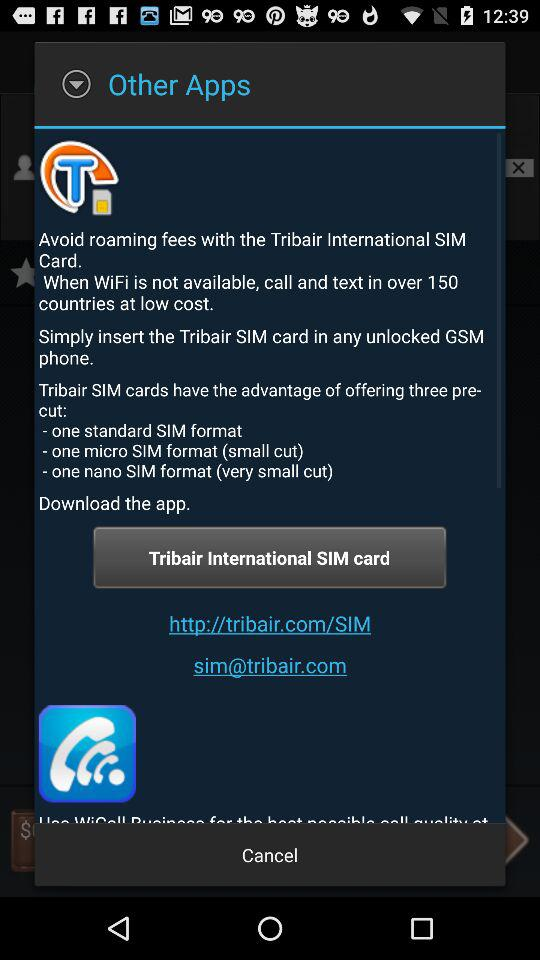How many SIM card formats does Tribair offer?
Answer the question using a single word or phrase. 3 